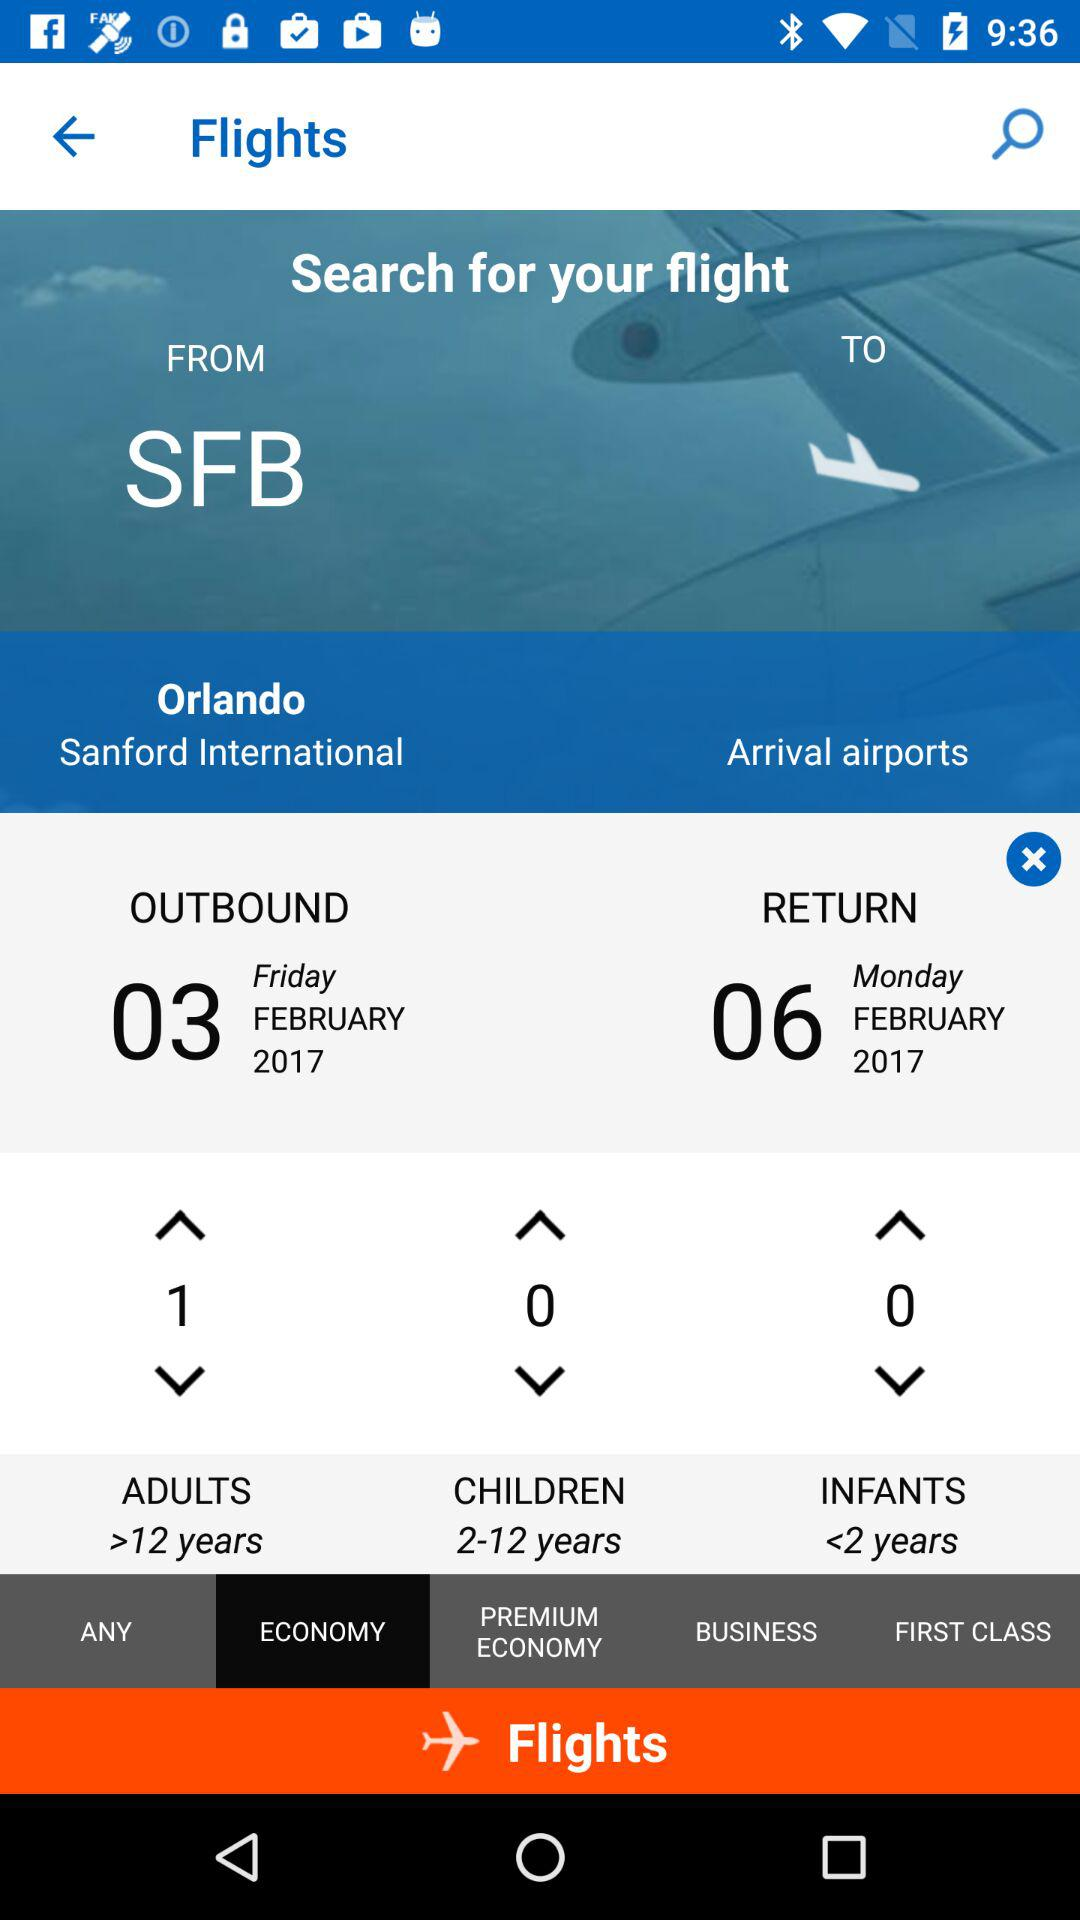What is the outbound date? The outbound date is Friday, February 3, 2017. 